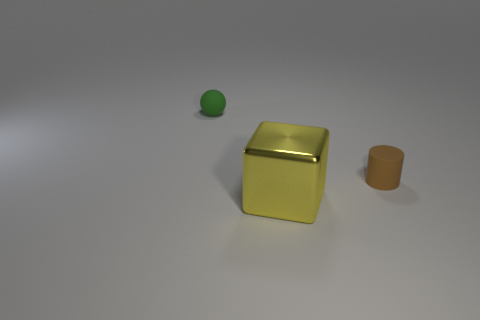Add 1 tiny green blocks. How many objects exist? 4 Subtract all cylinders. How many objects are left? 2 Subtract all spheres. Subtract all blue matte blocks. How many objects are left? 2 Add 1 tiny matte cylinders. How many tiny matte cylinders are left? 2 Add 1 large gray objects. How many large gray objects exist? 1 Subtract 0 red spheres. How many objects are left? 3 